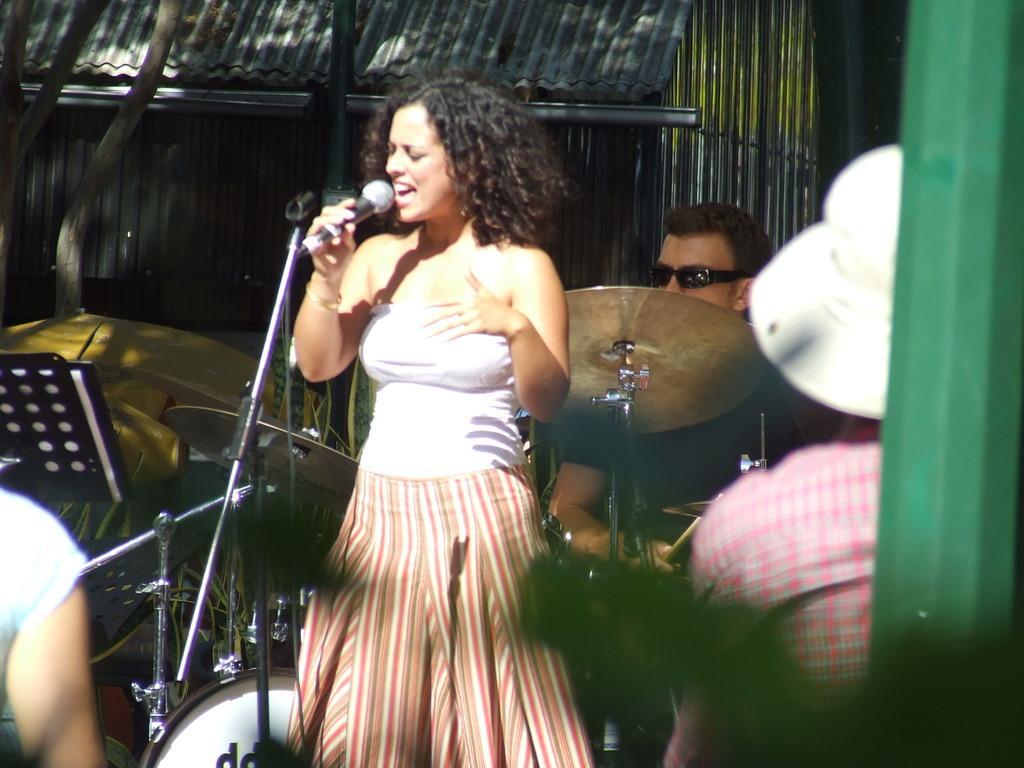Describe this image in one or two sentences. In this image we can see the person standing on the hand holding a mic and singing. And there are people sitting. One person playing a musical instrument and there is the shed, board and it looks like a tree trunk. 